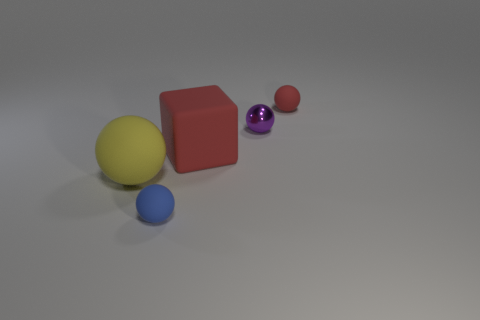The sphere that is the same color as the big block is what size?
Your answer should be compact. Small. How many yellow matte balls have the same size as the red block?
Provide a succinct answer. 1. Is the number of small metal things in front of the yellow rubber thing the same as the number of shiny spheres?
Offer a very short reply. No. What number of things are to the right of the large red thing and in front of the tiny red matte ball?
Make the answer very short. 1. There is a yellow object that is the same material as the small blue ball; what is its size?
Offer a very short reply. Large. How many small gray rubber objects are the same shape as the blue object?
Offer a very short reply. 0. Are there more small metallic spheres that are in front of the red sphere than big cyan cubes?
Make the answer very short. Yes. There is a thing that is both behind the tiny blue sphere and to the left of the big red cube; what is its shape?
Your answer should be very brief. Sphere. Do the yellow ball and the red ball have the same size?
Give a very brief answer. No. There is a tiny red matte sphere; how many small blue objects are in front of it?
Your answer should be compact. 1. 